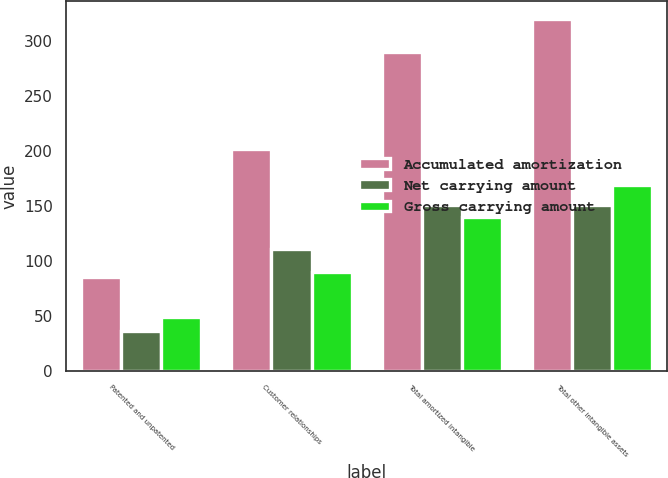Convert chart to OTSL. <chart><loc_0><loc_0><loc_500><loc_500><stacked_bar_chart><ecel><fcel>Patented and unpatented<fcel>Customer relationships<fcel>Total amortized intangible<fcel>Total other intangible assets<nl><fcel>Accumulated amortization<fcel>85.9<fcel>201.8<fcel>290.6<fcel>320.3<nl><fcel>Net carrying amount<fcel>36.5<fcel>111.4<fcel>150.8<fcel>150.8<nl><fcel>Gross carrying amount<fcel>49.4<fcel>90.4<fcel>139.8<fcel>169.5<nl></chart> 